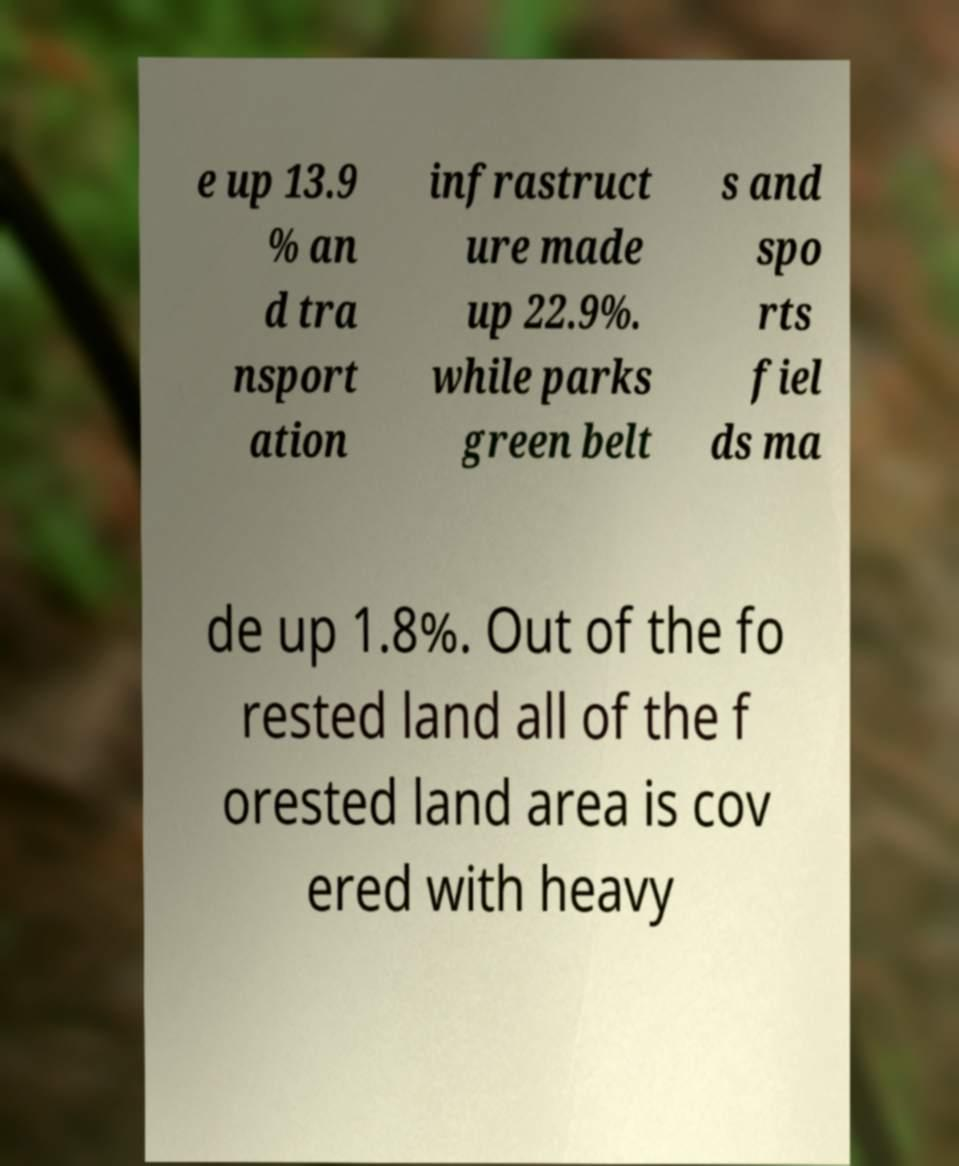What messages or text are displayed in this image? I need them in a readable, typed format. e up 13.9 % an d tra nsport ation infrastruct ure made up 22.9%. while parks green belt s and spo rts fiel ds ma de up 1.8%. Out of the fo rested land all of the f orested land area is cov ered with heavy 